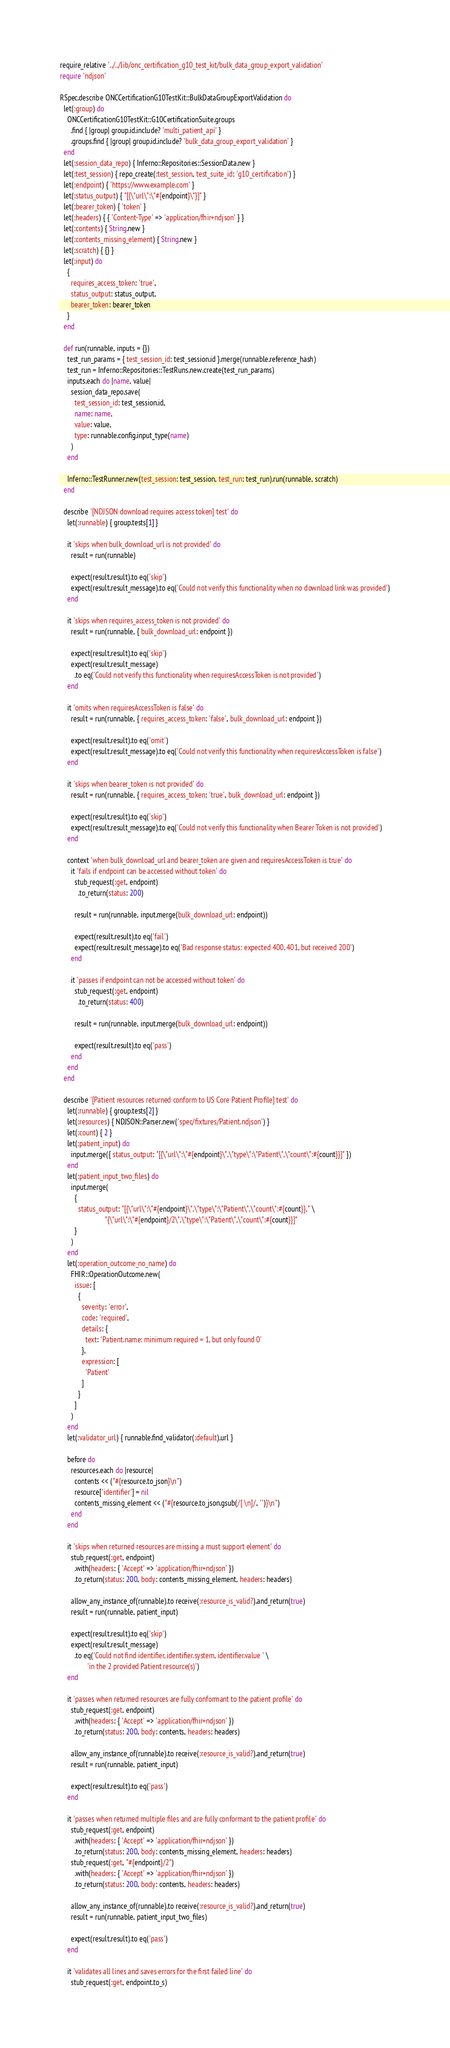Convert code to text. <code><loc_0><loc_0><loc_500><loc_500><_Ruby_>require_relative '../../lib/onc_certification_g10_test_kit/bulk_data_group_export_validation'
require 'ndjson'

RSpec.describe ONCCertificationG10TestKit::BulkDataGroupExportValidation do
  let(:group) do
    ONCCertificationG10TestKit::G10CertificationSuite.groups
      .find { |group| group.id.include? 'multi_patient_api' }
      .groups.find { |group| group.id.include? 'bulk_data_group_export_validation' }
  end
  let(:session_data_repo) { Inferno::Repositories::SessionData.new }
  let(:test_session) { repo_create(:test_session, test_suite_id: 'g10_certification') }
  let(:endpoint) { 'https://www.example.com' }
  let(:status_output) { "[{\"url\":\"#{endpoint}\"}]" }
  let(:bearer_token) { 'token' }
  let(:headers) { { 'Content-Type' => 'application/fhir+ndjson' } }
  let(:contents) { String.new }
  let(:contents_missing_element) { String.new }
  let(:scratch) { {} }
  let(:input) do
    {
      requires_access_token: 'true',
      status_output: status_output,
      bearer_token: bearer_token
    }
  end

  def run(runnable, inputs = {})
    test_run_params = { test_session_id: test_session.id }.merge(runnable.reference_hash)
    test_run = Inferno::Repositories::TestRuns.new.create(test_run_params)
    inputs.each do |name, value|
      session_data_repo.save(
        test_session_id: test_session.id,
        name: name,
        value: value,
        type: runnable.config.input_type(name)
      )
    end

    Inferno::TestRunner.new(test_session: test_session, test_run: test_run).run(runnable, scratch)
  end

  describe '[NDJSON download requires access token] test' do
    let(:runnable) { group.tests[1] }

    it 'skips when bulk_download_url is not provided' do
      result = run(runnable)

      expect(result.result).to eq('skip')
      expect(result.result_message).to eq('Could not verify this functionality when no download link was provided')
    end

    it 'skips when requires_access_token is not provided' do
      result = run(runnable, { bulk_download_url: endpoint })

      expect(result.result).to eq('skip')
      expect(result.result_message)
        .to eq('Could not verify this functionality when requiresAccessToken is not provided')
    end

    it 'omits when requiresAccessToken is false' do
      result = run(runnable, { requires_access_token: 'false', bulk_download_url: endpoint })

      expect(result.result).to eq('omit')
      expect(result.result_message).to eq('Could not verify this functionality when requiresAccessToken is false')
    end

    it 'skips when bearer_token is not provided' do
      result = run(runnable, { requires_access_token: 'true', bulk_download_url: endpoint })

      expect(result.result).to eq('skip')
      expect(result.result_message).to eq('Could not verify this functionality when Bearer Token is not provided')
    end

    context 'when bulk_download_url and bearer_token are given and requiresAccessToken is true' do
      it 'fails if endpoint can be accessed without token' do
        stub_request(:get, endpoint)
          .to_return(status: 200)

        result = run(runnable, input.merge(bulk_download_url: endpoint))

        expect(result.result).to eq('fail')
        expect(result.result_message).to eq('Bad response status: expected 400, 401, but received 200')
      end

      it 'passes if endpoint can not be accessed without token' do
        stub_request(:get, endpoint)
          .to_return(status: 400)

        result = run(runnable, input.merge(bulk_download_url: endpoint))

        expect(result.result).to eq('pass')
      end
    end
  end

  describe '[Patient resources returned conform to US Core Patient Profile] test' do
    let(:runnable) { group.tests[2] }
    let(:resources) { NDJSON::Parser.new('spec/fixtures/Patient.ndjson') }
    let(:count) { 2 }
    let(:patient_input) do
      input.merge({ status_output: "[{\"url\":\"#{endpoint}\",\"type\":\"Patient\",\"count\":#{count}}]" })
    end
    let(:patient_input_two_files) do
      input.merge(
        {
          status_output: "[{\"url\":\"#{endpoint}\",\"type\":\"Patient\",\"count\":#{count}}," \
                         "{\"url\":\"#{endpoint}/2\",\"type\":\"Patient\",\"count\":#{count}}]"
        }
      )
    end
    let(:operation_outcome_no_name) do
      FHIR::OperationOutcome.new(
        issue: [
          {
            severity: 'error',
            code: 'required',
            details: {
              text: 'Patient.name: minimum required = 1, but only found 0'
            },
            expression: [
              'Patient'
            ]
          }
        ]
      )
    end
    let(:validator_url) { runnable.find_validator(:default).url }

    before do
      resources.each do |resource|
        contents << ("#{resource.to_json}\n")
        resource['identifier'] = nil
        contents_missing_element << ("#{resource.to_json.gsub(/[ \n]/, '')}\n")
      end
    end

    it 'skips when returned resources are missing a must support element' do
      stub_request(:get, endpoint)
        .with(headers: { 'Accept' => 'application/fhir+ndjson' })
        .to_return(status: 200, body: contents_missing_element, headers: headers)

      allow_any_instance_of(runnable).to receive(:resource_is_valid?).and_return(true)
      result = run(runnable, patient_input)

      expect(result.result).to eq('skip')
      expect(result.result_message)
        .to eq('Could not find identifier, identifier.system, identifier.value ' \
               'in the 2 provided Patient resource(s)')
    end

    it 'passes when returned resources are fully conformant to the patient profile' do
      stub_request(:get, endpoint)
        .with(headers: { 'Accept' => 'application/fhir+ndjson' })
        .to_return(status: 200, body: contents, headers: headers)

      allow_any_instance_of(runnable).to receive(:resource_is_valid?).and_return(true)
      result = run(runnable, patient_input)

      expect(result.result).to eq('pass')
    end

    it 'passes when returned multiple files and are fully conformant to the patient profile' do
      stub_request(:get, endpoint)
        .with(headers: { 'Accept' => 'application/fhir+ndjson' })
        .to_return(status: 200, body: contents_missing_element, headers: headers)
      stub_request(:get, "#{endpoint}/2")
        .with(headers: { 'Accept' => 'application/fhir+ndjson' })
        .to_return(status: 200, body: contents, headers: headers)

      allow_any_instance_of(runnable).to receive(:resource_is_valid?).and_return(true)
      result = run(runnable, patient_input_two_files)

      expect(result.result).to eq('pass')
    end

    it 'validates all lines and saves errors for the first failed line' do
      stub_request(:get, endpoint.to_s)</code> 